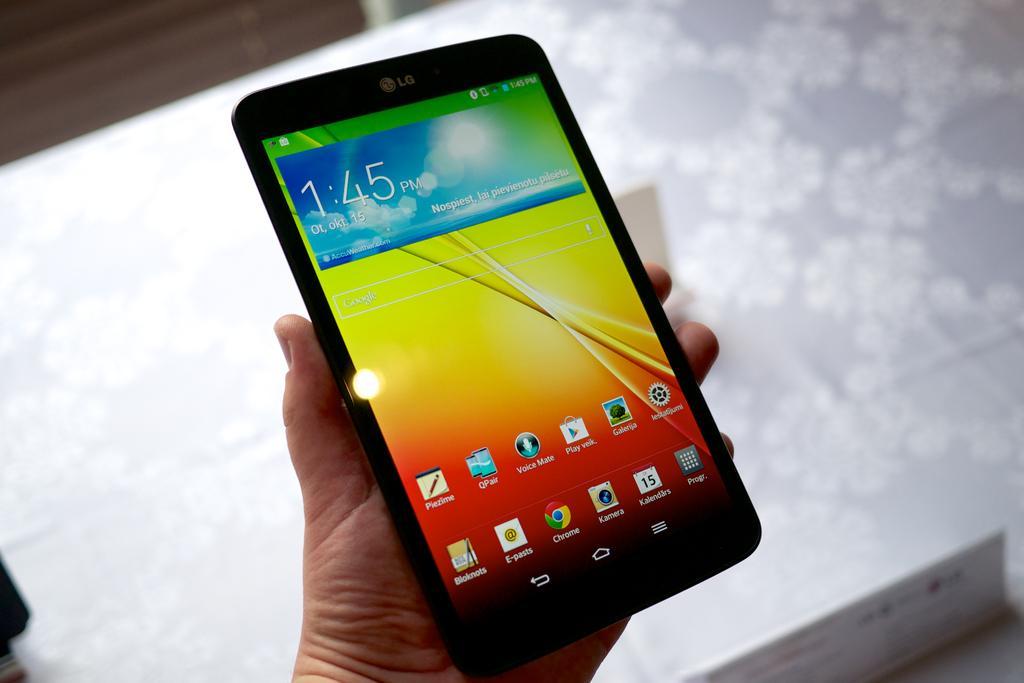Can you describe this image briefly? In this picture I can see at the bottom it looks like a human hand is holding a tab. 